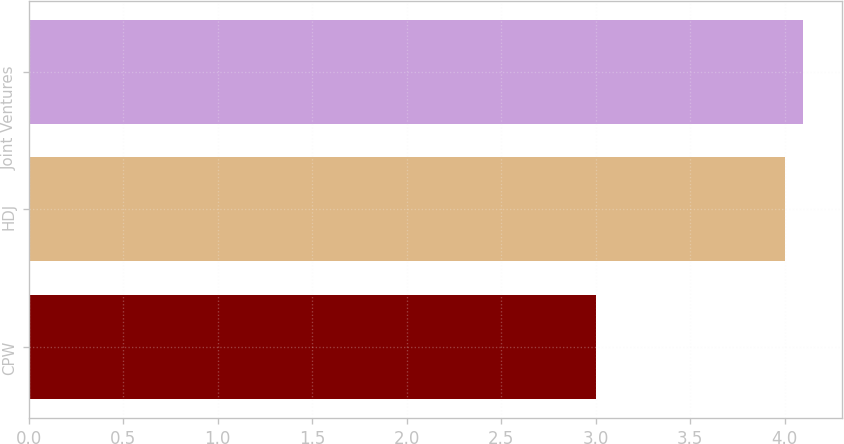Convert chart to OTSL. <chart><loc_0><loc_0><loc_500><loc_500><bar_chart><fcel>CPW<fcel>HDJ<fcel>Joint Ventures<nl><fcel>3<fcel>4<fcel>4.1<nl></chart> 